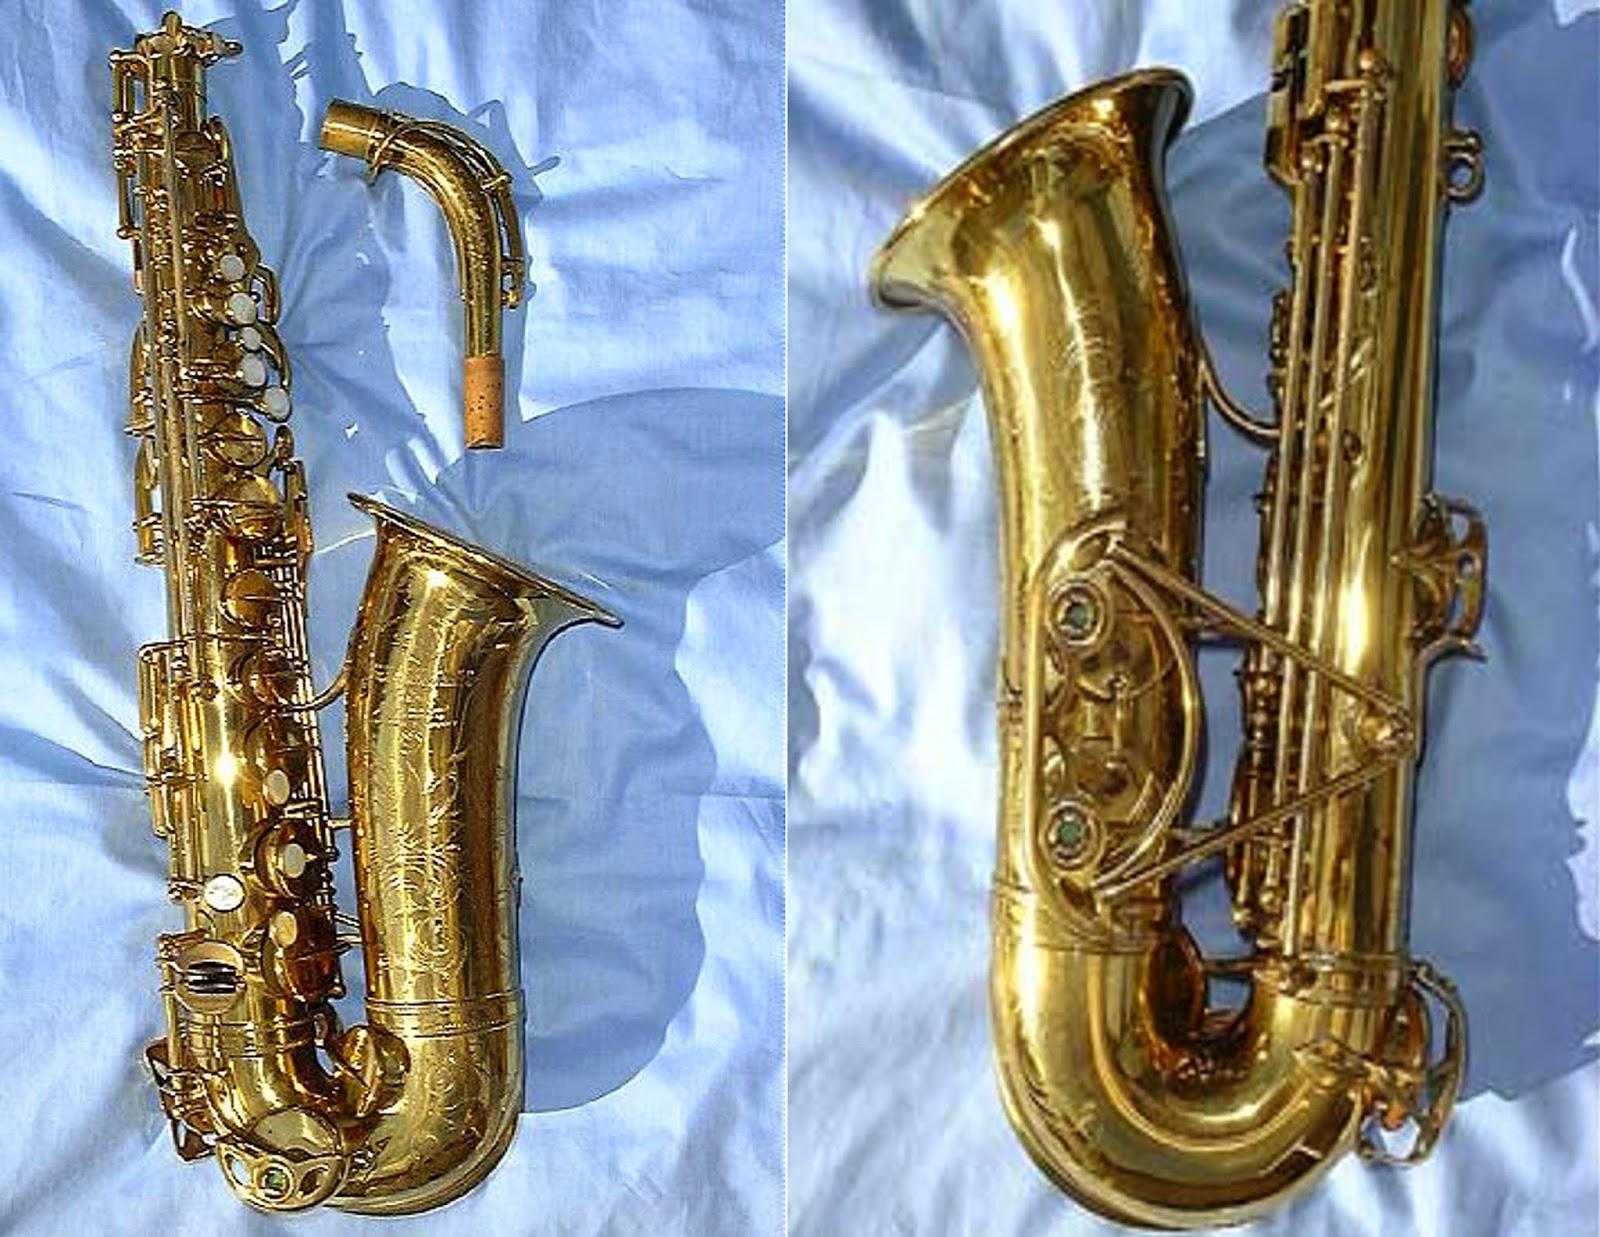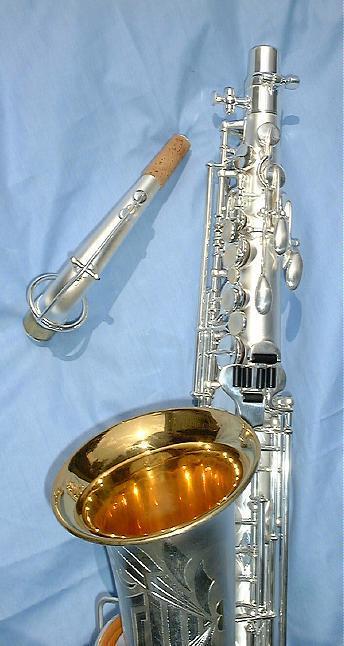The first image is the image on the left, the second image is the image on the right. For the images displayed, is the sentence "There are only two saxophones." factually correct? Answer yes or no. No. 